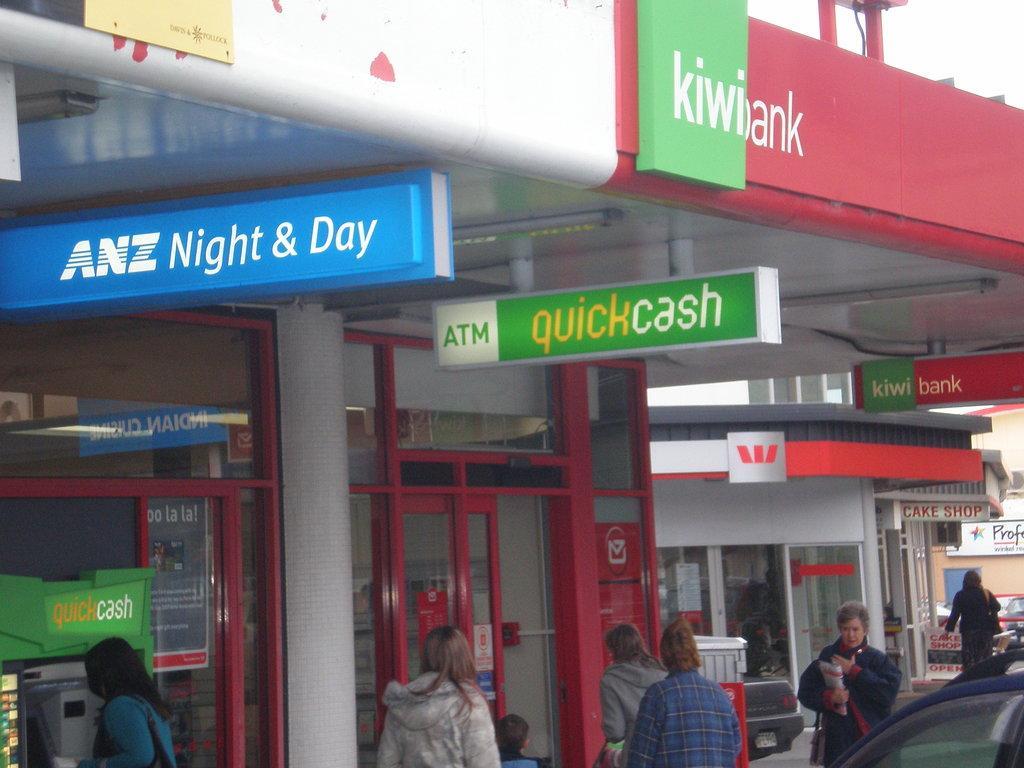Can you describe this image briefly? In this image there is a building with name kiwibank, also we can see there are people walking in front of that. 